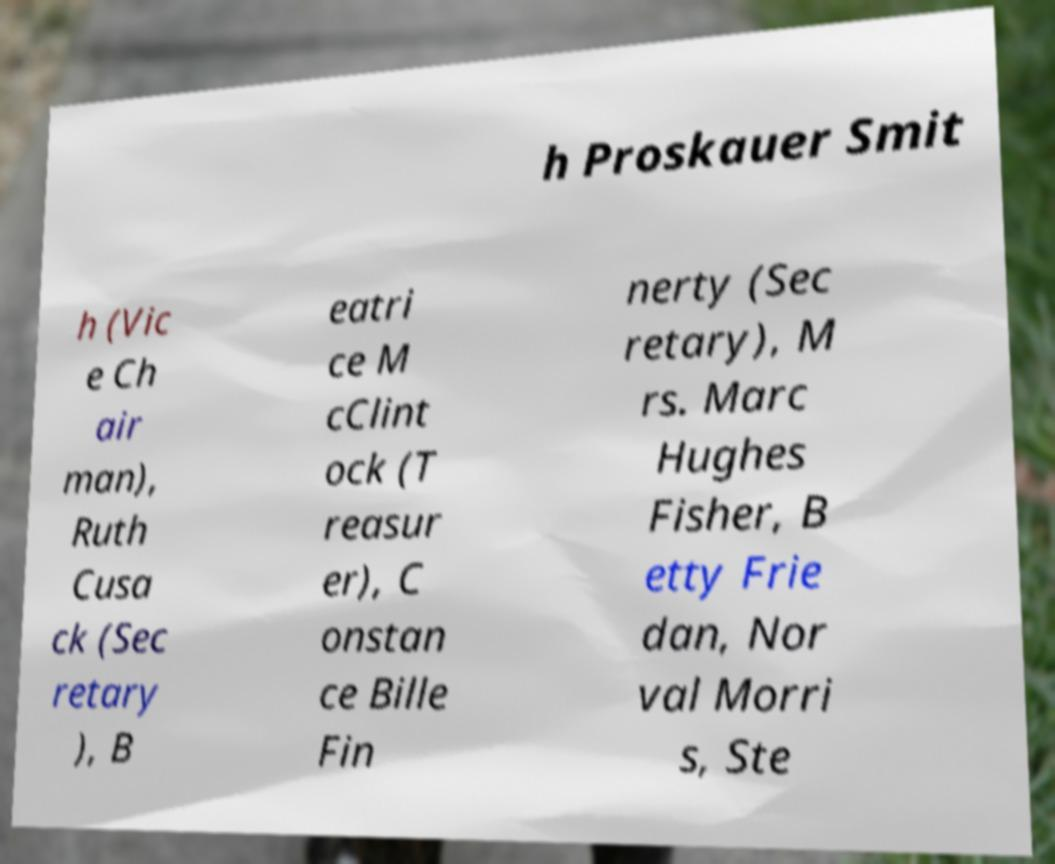I need the written content from this picture converted into text. Can you do that? h Proskauer Smit h (Vic e Ch air man), Ruth Cusa ck (Sec retary ), B eatri ce M cClint ock (T reasur er), C onstan ce Bille Fin nerty (Sec retary), M rs. Marc Hughes Fisher, B etty Frie dan, Nor val Morri s, Ste 